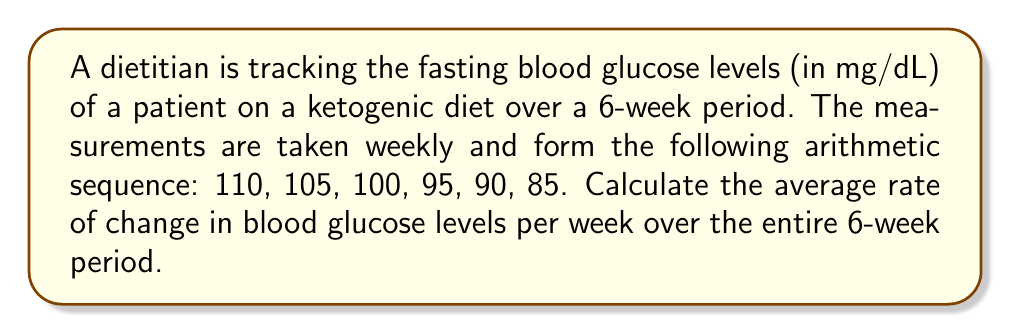Help me with this question. To calculate the average rate of change, we need to follow these steps:

1. Identify the first and last terms of the sequence:
   First term (a₁) = 110 mg/dL
   Last term (a₆) = 85 mg/dL

2. Calculate the total change in blood glucose levels:
   Total change = a₆ - a₁ = 85 - 110 = -25 mg/dL

3. Determine the time interval:
   Time interval = 6 weeks

4. Calculate the average rate of change using the formula:
   $$\text{Average rate of change} = \frac{\text{Total change}}{\text{Time interval}}$$

   $$\text{Average rate of change} = \frac{-25 \text{ mg/dL}}{6 \text{ weeks}}$$

5. Simplify the fraction:
   $$\text{Average rate of change} = -\frac{25}{6} \text{ mg/dL per week}$$

Therefore, the average rate of change in blood glucose levels is -25/6 mg/dL per week, or approximately -4.17 mg/dL per week.
Answer: $-\frac{25}{6}$ mg/dL per week 